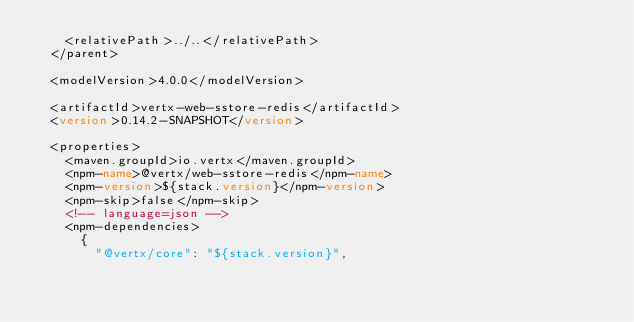<code> <loc_0><loc_0><loc_500><loc_500><_XML_>    <relativePath>../..</relativePath>
  </parent>

  <modelVersion>4.0.0</modelVersion>

  <artifactId>vertx-web-sstore-redis</artifactId>
  <version>0.14.2-SNAPSHOT</version>

  <properties>
    <maven.groupId>io.vertx</maven.groupId>
    <npm-name>@vertx/web-sstore-redis</npm-name>
    <npm-version>${stack.version}</npm-version>
    <npm-skip>false</npm-skip>
    <!-- language=json -->
    <npm-dependencies>
      {
        "@vertx/core": "${stack.version}",</code> 